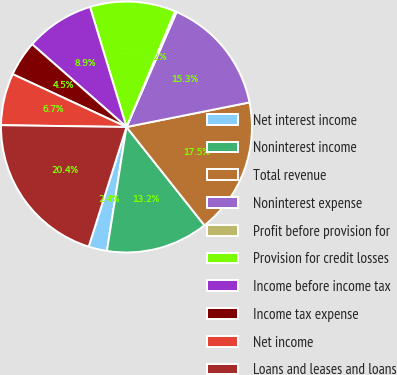Convert chart. <chart><loc_0><loc_0><loc_500><loc_500><pie_chart><fcel>Net interest income<fcel>Noninterest income<fcel>Total revenue<fcel>Noninterest expense<fcel>Profit before provision for<fcel>Provision for credit losses<fcel>Income before income tax<fcel>Income tax expense<fcel>Net income<fcel>Loans and leases and loans<nl><fcel>2.38%<fcel>13.16%<fcel>17.47%<fcel>15.32%<fcel>0.22%<fcel>11.01%<fcel>8.85%<fcel>4.54%<fcel>6.69%<fcel>20.36%<nl></chart> 